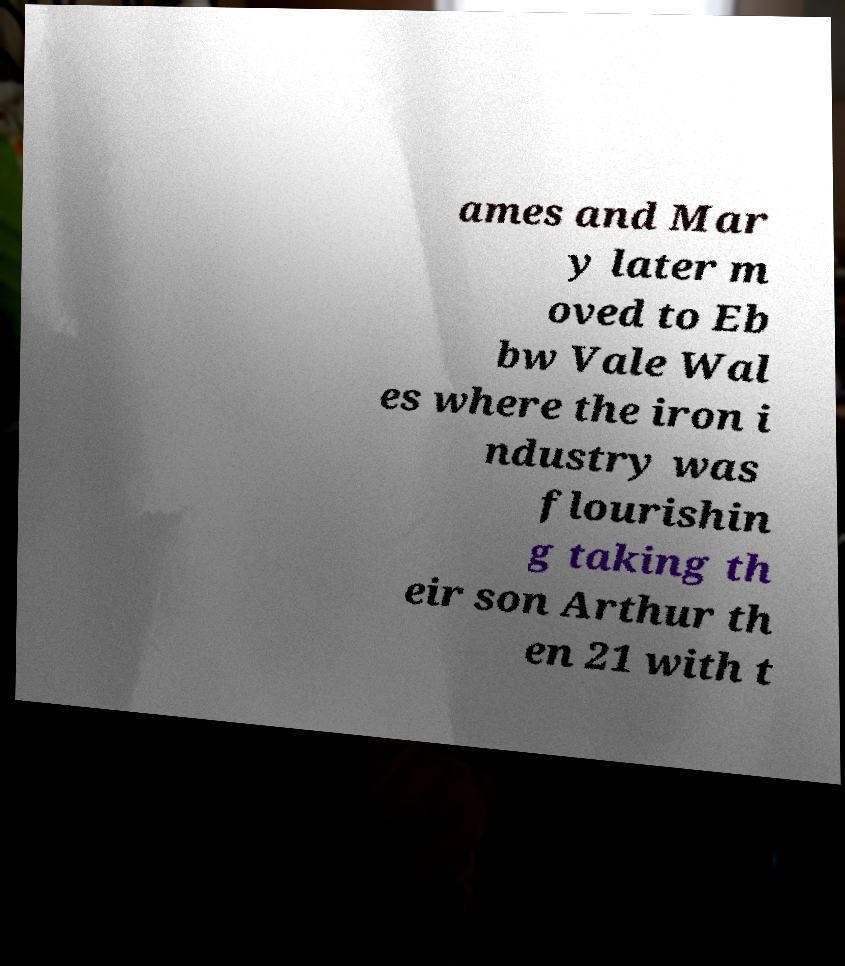Could you extract and type out the text from this image? ames and Mar y later m oved to Eb bw Vale Wal es where the iron i ndustry was flourishin g taking th eir son Arthur th en 21 with t 